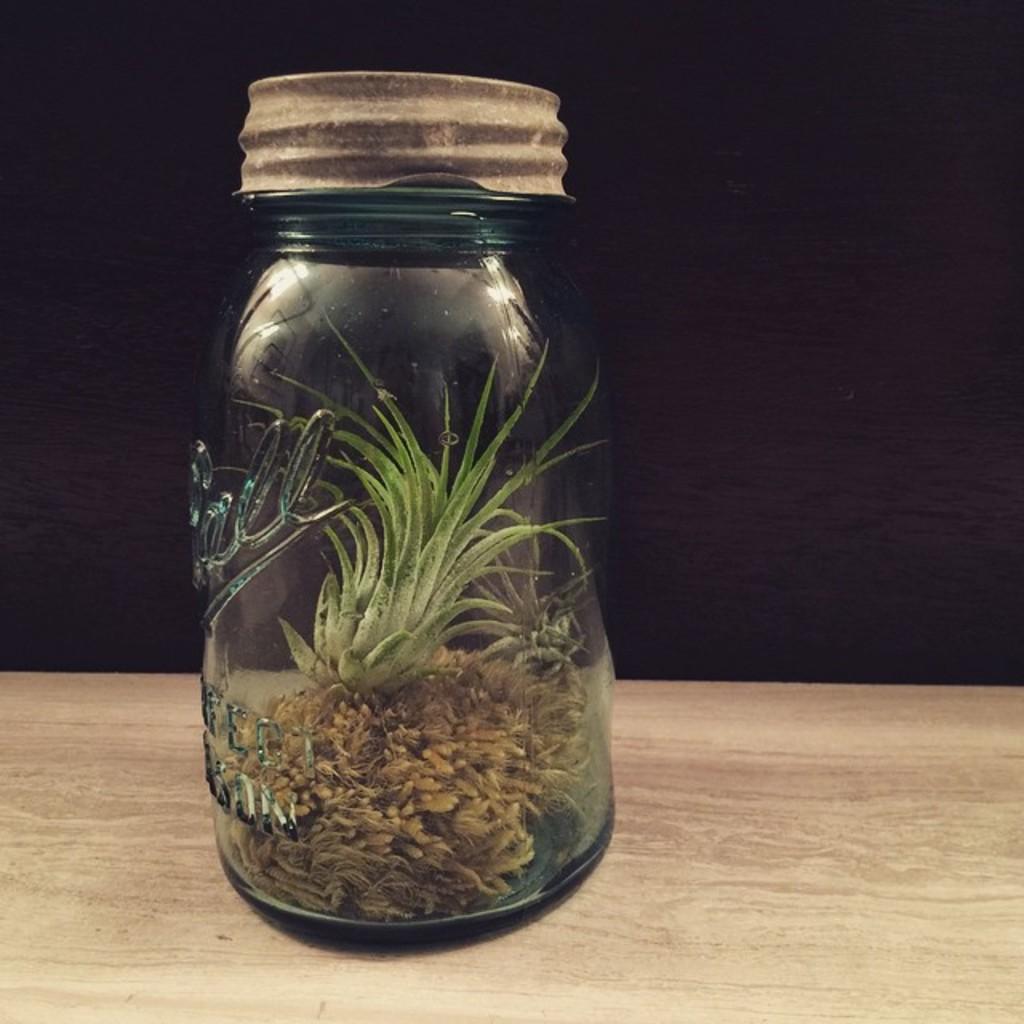Please provide a concise description of this image. In this image we can see plants in a jar placed on the wooden surface. 